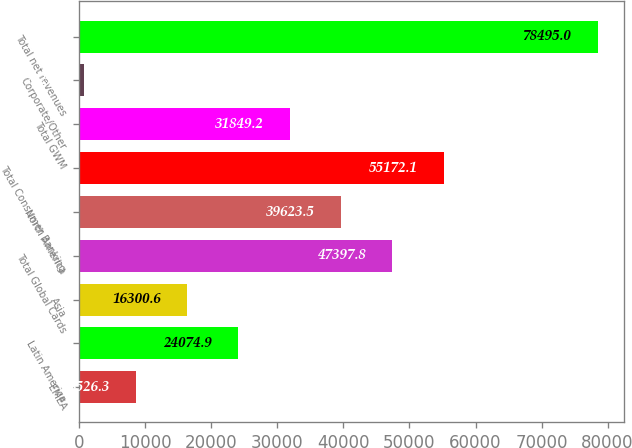<chart> <loc_0><loc_0><loc_500><loc_500><bar_chart><fcel>EMEA<fcel>Latin America<fcel>Asia<fcel>Total Global Cards<fcel>North America<fcel>Total Consumer Banking<fcel>Total GWM<fcel>Corporate/Other<fcel>Total net revenues<nl><fcel>8526.3<fcel>24074.9<fcel>16300.6<fcel>47397.8<fcel>39623.5<fcel>55172.1<fcel>31849.2<fcel>752<fcel>78495<nl></chart> 